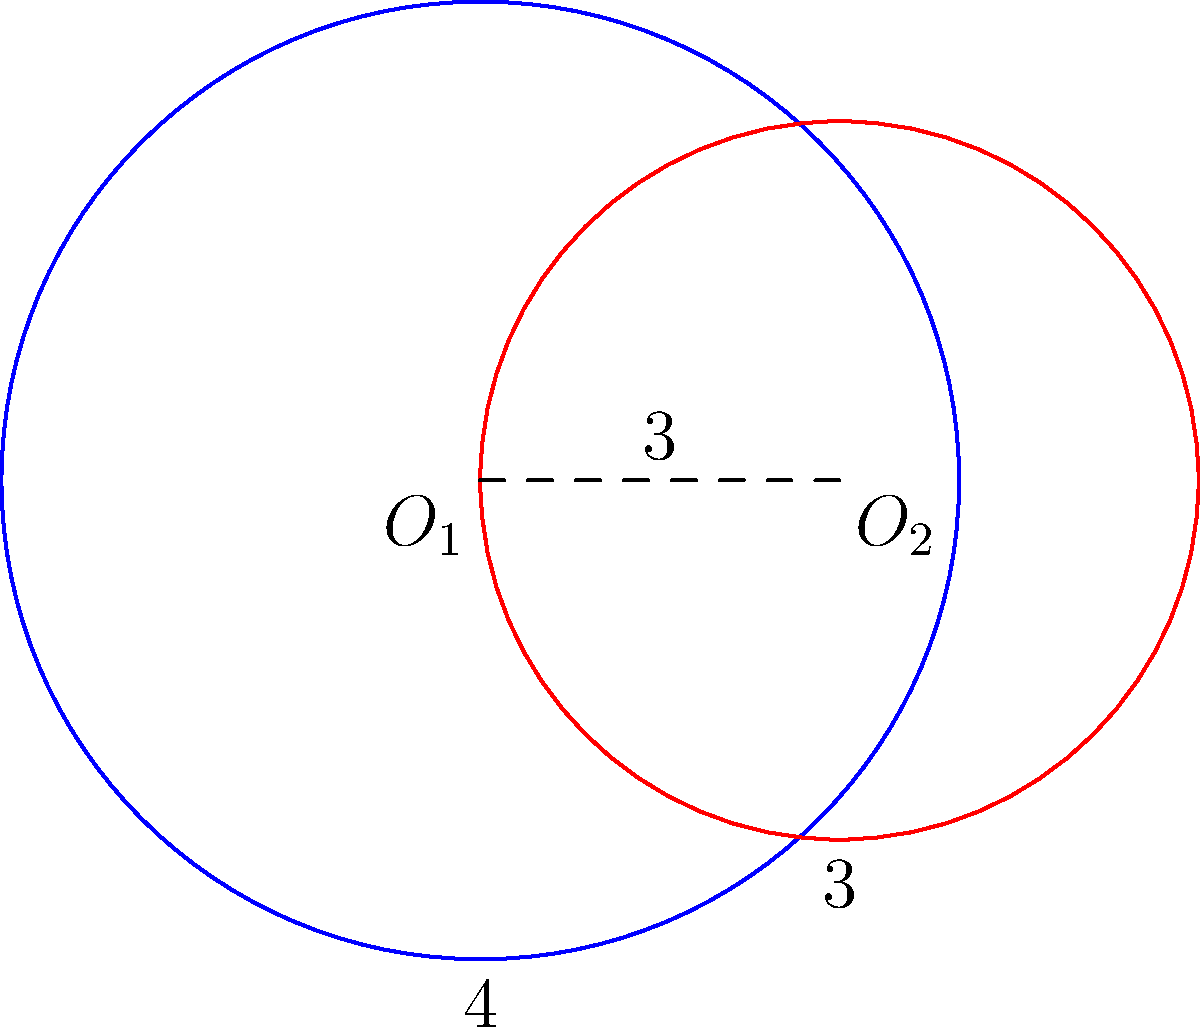In an environmental impact study of two overlapping ecosystems, you're analyzing the intersection of two circular habitats. The centers of the habitats are 3 units apart. The radius of the larger habitat (blue) is 4 units, while the smaller habitat (red) has a radius of 3 units. What percentage of the smaller habitat's area is not shared with the larger habitat? Round your answer to the nearest whole percent. Let's approach this step-by-step:

1) First, we need to find the area of intersection between the two circles. We can use the formula for the area of intersection of two circles:

   $$A = r_1^2 \arccos(\frac{d^2 + r_1^2 - r_2^2}{2dr_1}) + r_2^2 \arccos(\frac{d^2 + r_2^2 - r_1^2}{2dr_2}) - \frac{1}{2}\sqrt{(-d+r_1+r_2)(d+r_1-r_2)(d-r_1+r_2)(d+r_1+r_2)}$$

   Where $r_1 = 4$, $r_2 = 3$, and $d = 3$ (the distance between centers)

2) Plugging in these values:

   $$A = 16 \arccos(\frac{9 + 16 - 9}{24}) + 9 \arccos(\frac{9 + 9 - 16}{18}) - \frac{1}{2}\sqrt{(-3+4+3)(3+4-3)(3-4+3)(3+4+3)}$$

3) Simplifying:

   $$A = 16 \arccos(\frac{2}{3}) + 9 \arccos(\frac{1}{9}) - \frac{1}{2}\sqrt{4 \cdot 4 \cdot 2 \cdot 10}$$

4) Calculating:

   $$A \approx 16 \cdot 0.8411 + 9 \cdot 1.4457 - \frac{1}{2}\sqrt{320} \approx 13.4576 + 13.0113 - 8.9443 \approx 17.5246$$

5) The area of the smaller circle (red) is $\pi r^2 = \pi \cdot 3^2 = 9\pi \approx 28.2743$

6) The area of the smaller circle not shared with the larger circle is:

   $$28.2743 - 17.5246 = 10.7497$$

7) The percentage of the smaller habitat's area not shared is:

   $$\frac{10.7497}{28.2743} \cdot 100\% \approx 38.02\%$$

8) Rounding to the nearest whole percent: 38%
Answer: 38% 